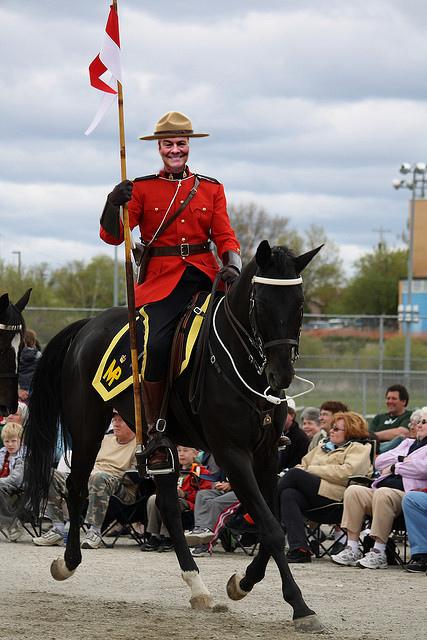What is the person on the horse holding?
Concise answer only. Flag. Does this person live in Mexico?
Be succinct. No. What kind of hat is this man wearing?
Be succinct. Mountie hat. 